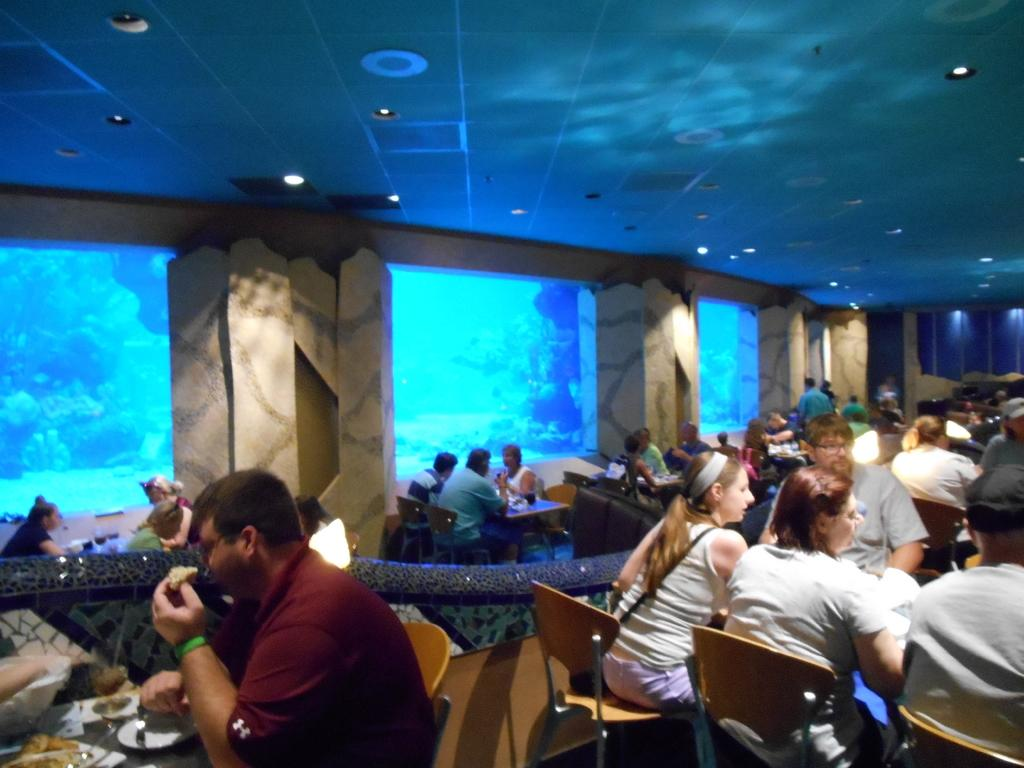What are the persons in the image doing? The persons in the image are sitting in chairs. What is in front of the persons? There is a table in front of the persons. What can be seen on the table? There are objects placed on the table. What type of beast is causing chaos on the table in the image? There is no beast present in the image, and the table is not depicted as being in chaos. 